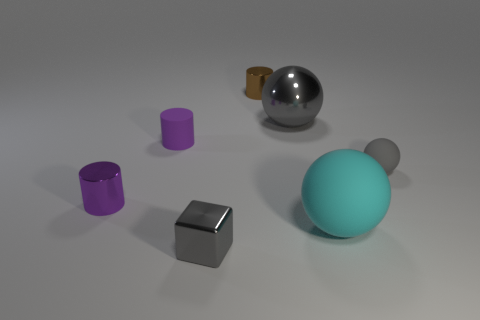Subtract all purple cylinders. How many cylinders are left? 1 Subtract all brown cylinders. How many cylinders are left? 2 Add 1 cyan things. How many objects exist? 8 Subtract all yellow cylinders. How many gray balls are left? 2 Subtract all balls. How many objects are left? 4 Add 7 cyan rubber things. How many cyan rubber things exist? 8 Subtract 0 yellow spheres. How many objects are left? 7 Subtract 2 balls. How many balls are left? 1 Subtract all blue spheres. Subtract all green cylinders. How many spheres are left? 3 Subtract all large purple cylinders. Subtract all small purple metal cylinders. How many objects are left? 6 